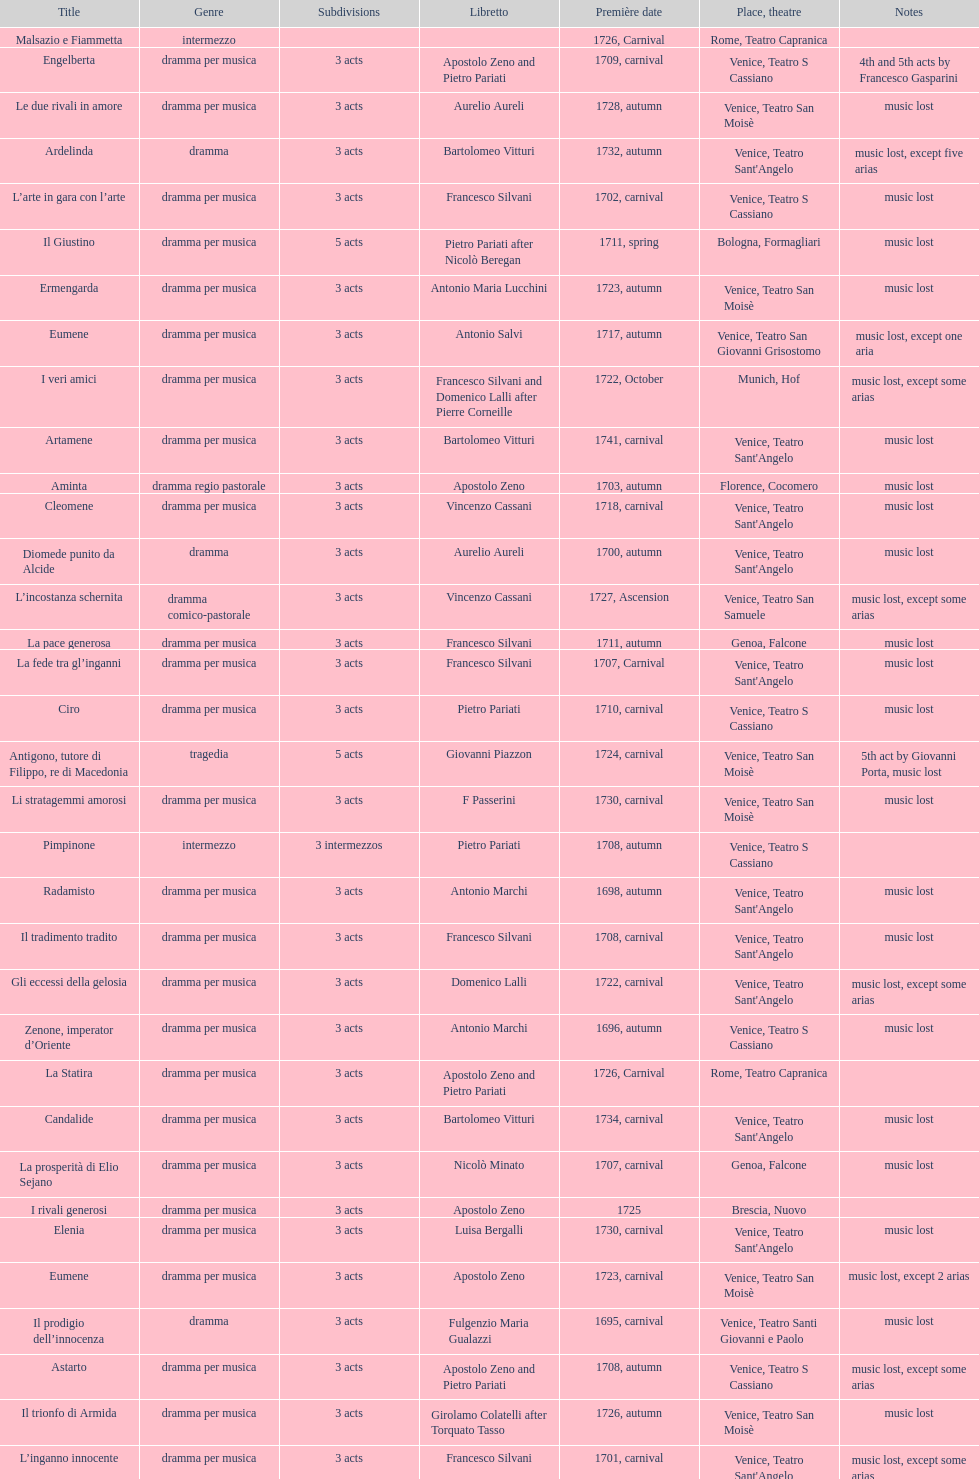Which was released earlier, artamene or merope? Merope. 